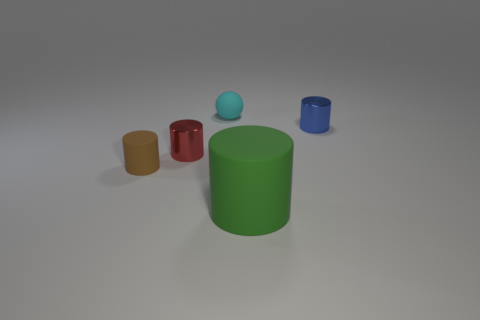Which objects in the image appear to be the tallest and the shortest? The green cylinder stands out as the tallest object, while the blue ball appears to be the shortest in the image. 